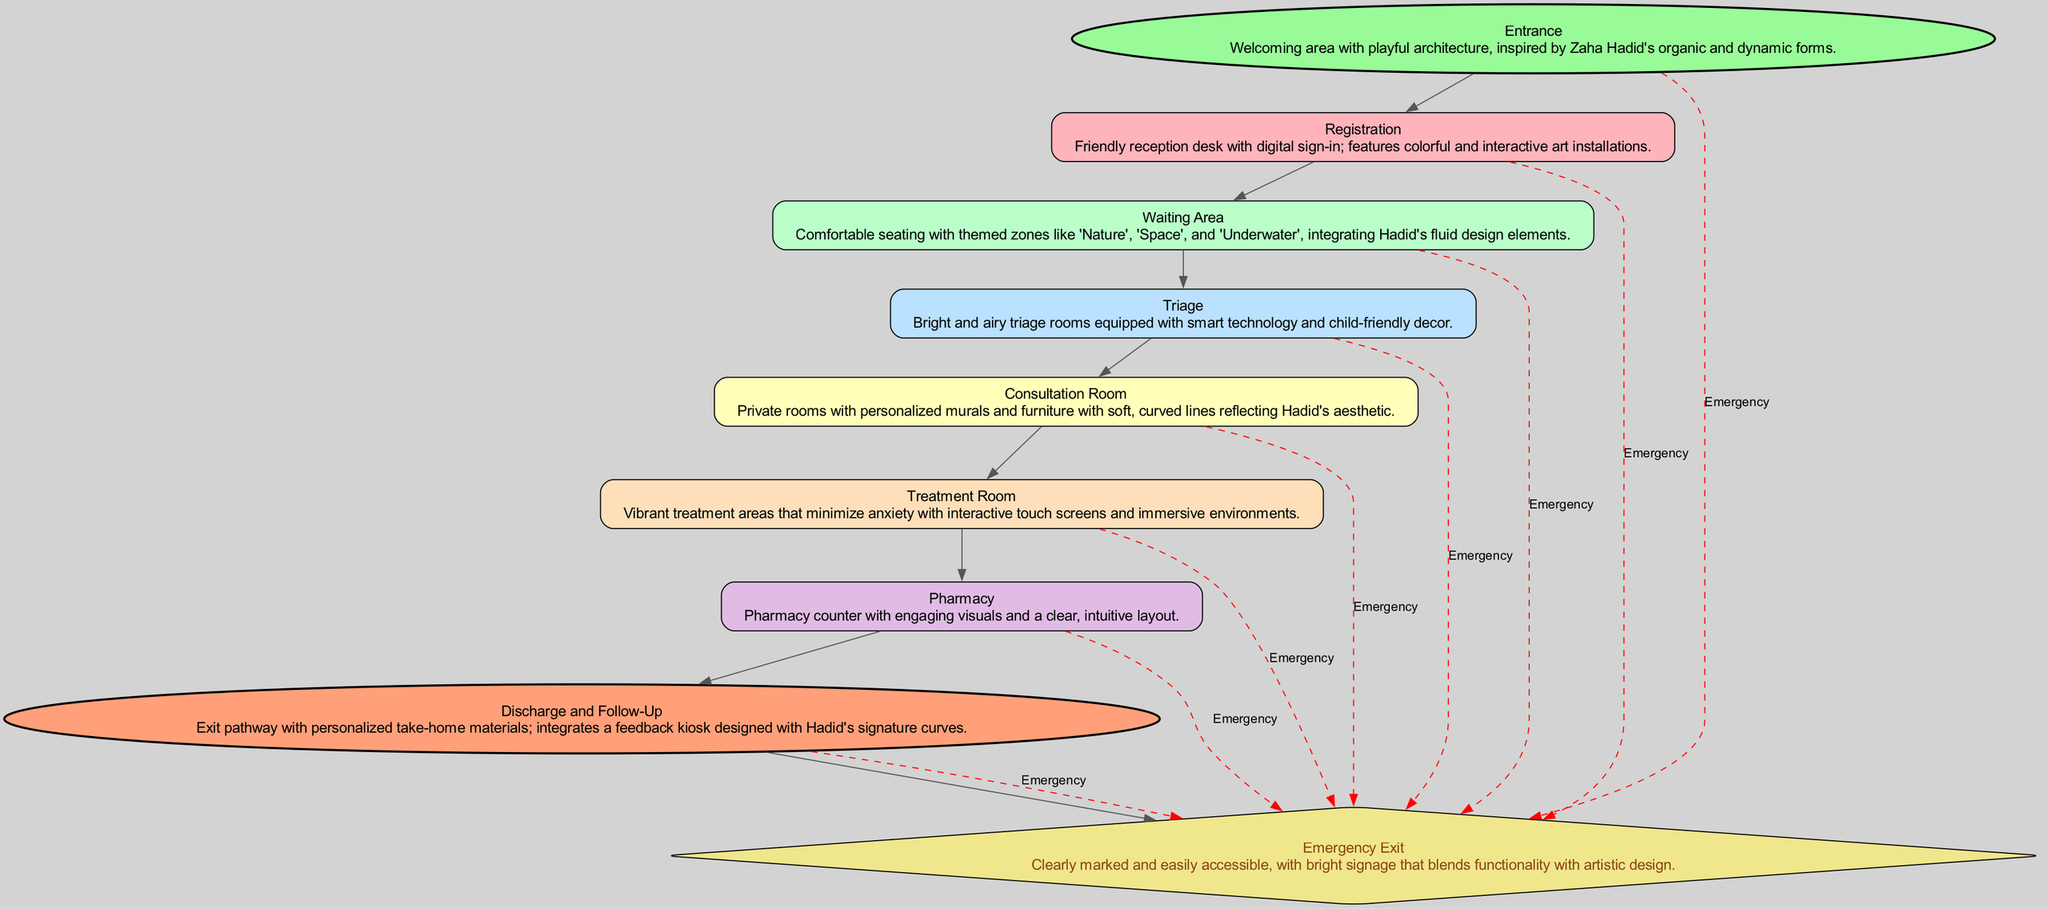What is the first step in the pathway? The diagram indicates that the first step, or starting point, in the pathway is the "Entrance." This is confirmed by its classification as a "Start" type in the diagram.
Answer: Entrance How many themed zones are in the Waiting Area? The diagram specifies that the Waiting Area has themed zones such as 'Nature', 'Space', and 'Underwater.' By counting these themes, we find that there are three distinct zones.
Answer: 3 What type of design does the Consultation Room reflect? The description of the Consultation Room states that it has furniture with soft, curved lines that reflect Hadid's aesthetic. This indicates a design inspiration specifically tied to Zaha Hadid's unique style.
Answer: Hadid's aesthetic What do patients receive at the Discharge and Follow-Up step? The Discharge and Follow-Up step mentions that patients are provided with personalized take-home materials. This detail reveals the type of support patients receive upon exiting the pathway.
Answer: take-home materials Which room has the brightest and airiest decor? According to the diagram, the Triage room is described as being bright and airy, making it the space that embodies these characteristics most strongly within the pathway.
Answer: Triage What is the relationship between the Treatment Room and the Pharmacy? The diagram shows that the Treatment Room comes directly before the Pharmacy in the flow sequence. This indicates that patients progress from Treatment Room to Pharmacy as part of the pathway.
Answer: sequential How is the Emergency Exit marked in the diagram? The Emergency Exit is described as clearly marked and easily accessible. Additionally, it features bright signage that combines functionality with artistic design, ensuring it stands out for safety.
Answer: clearly marked What type of art installations are featured at the Registration step? The Registration step in the pathway mentions that there are colorful and interactive art installations. This indicates a focus on creating an engaging visual environment at this point in the process.
Answer: interactive art installations What color represents the End node in the diagram? The diagram describes the End node as being filled with a color that is light coral, specifically indicated as "#FFA07A," which denotes its categorized role as the concluding element in the pathway.
Answer: light coral 